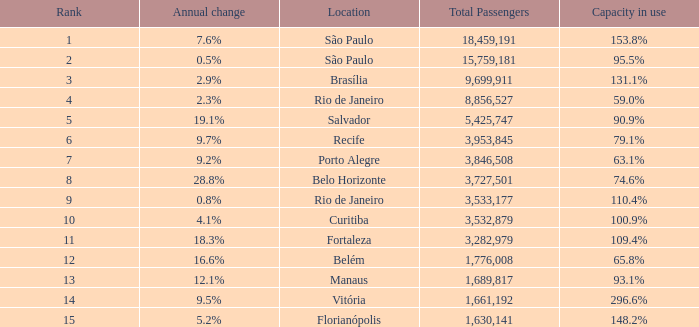What is the total number of Total Passengers when the annual change is 28.8% and the rank is less than 8? 0.0. 